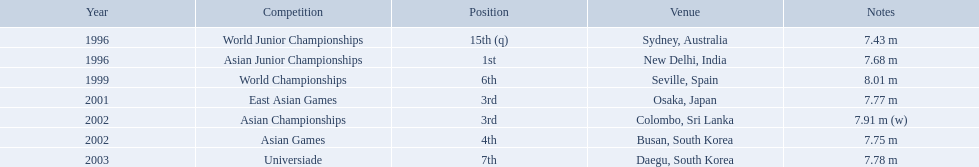What competitions did huang le compete in? World Junior Championships, Asian Junior Championships, World Championships, East Asian Games, Asian Championships, Asian Games, Universiade. What distances did he achieve in these competitions? 7.43 m, 7.68 m, 8.01 m, 7.77 m, 7.91 m (w), 7.75 m, 7.78 m. Which of these distances was the longest? 7.91 m (w). 